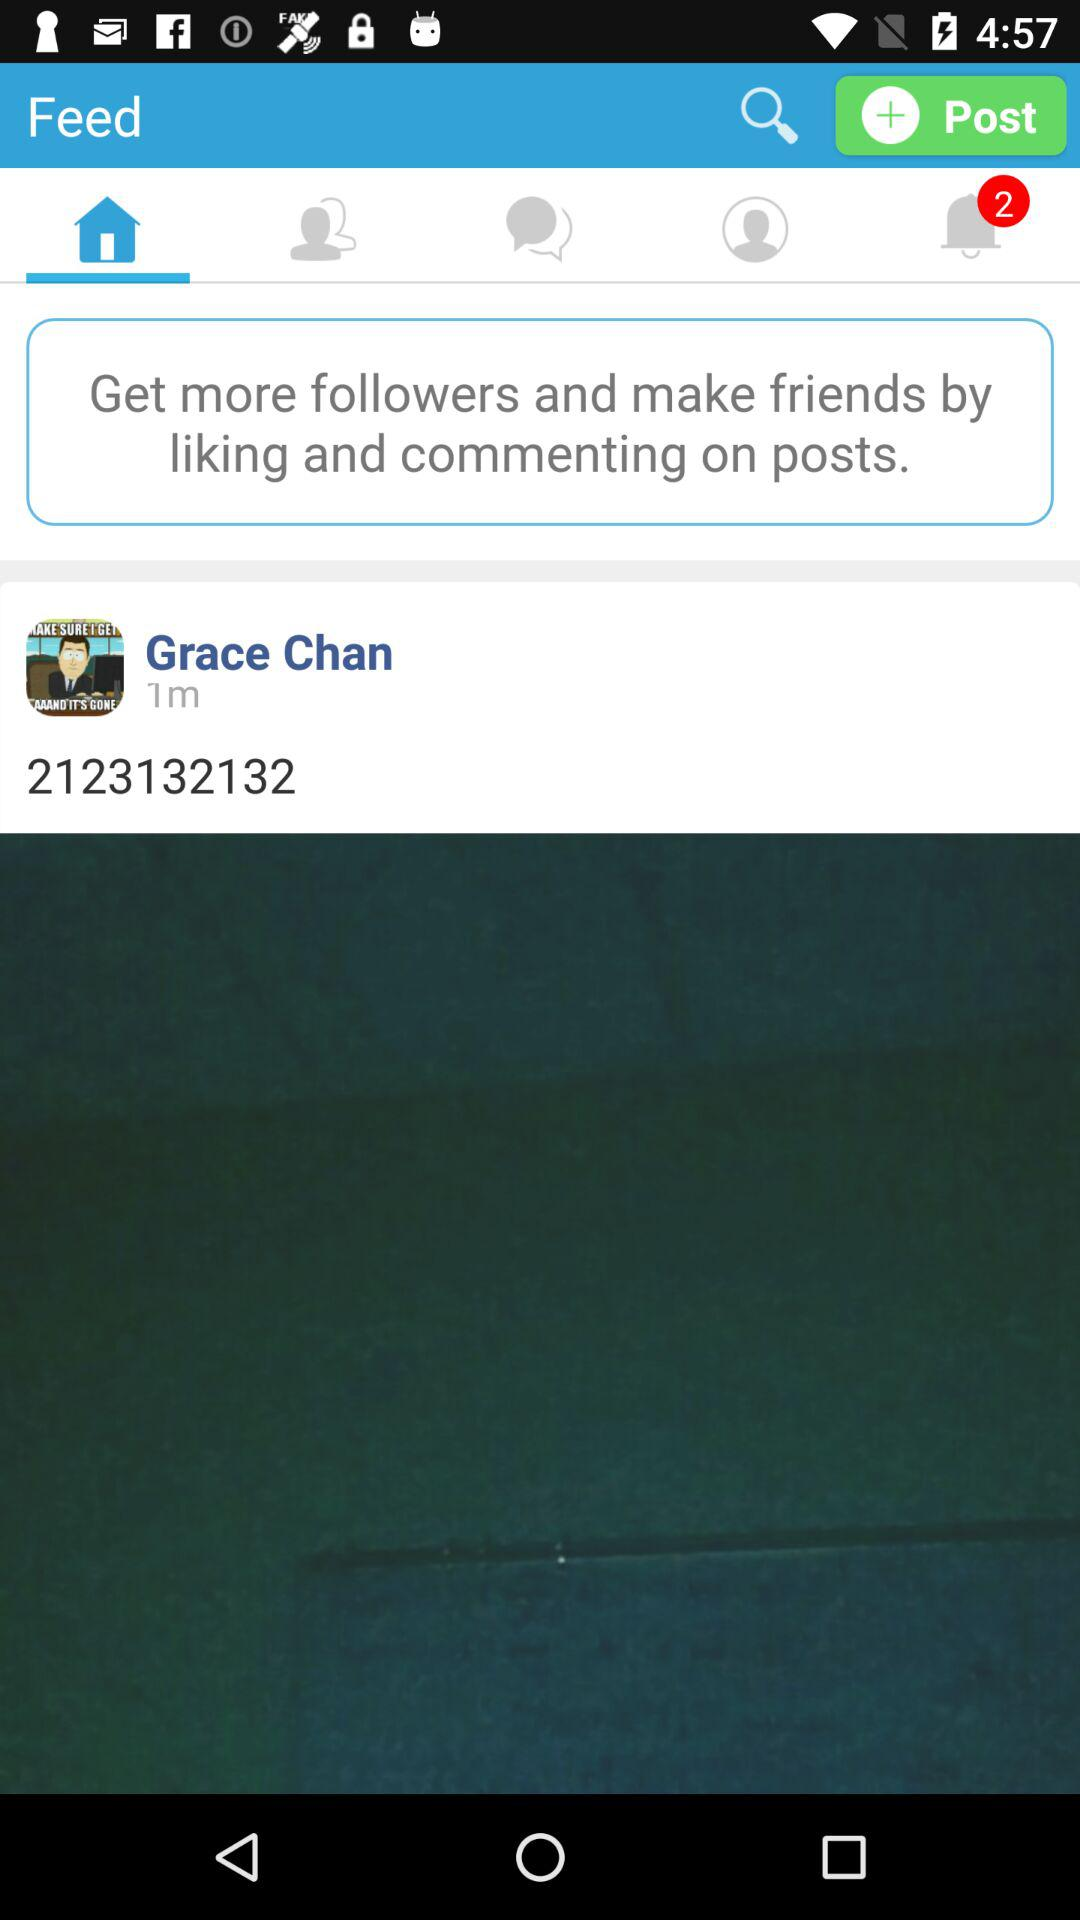How many unread messages are there?
When the provided information is insufficient, respond with <no answer>. <no answer> 